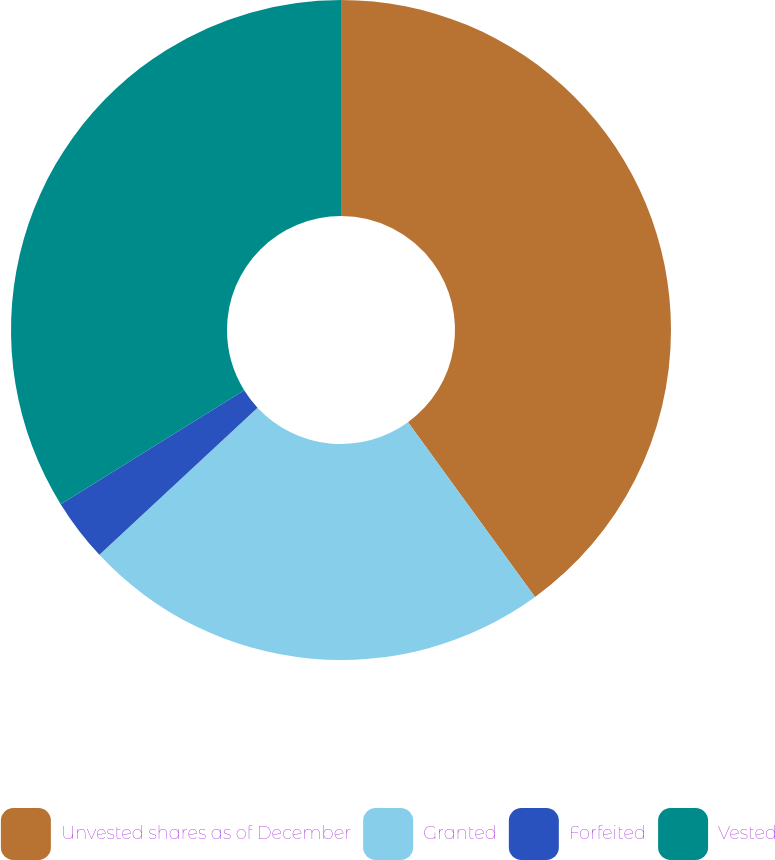Convert chart to OTSL. <chart><loc_0><loc_0><loc_500><loc_500><pie_chart><fcel>Unvested shares as of December<fcel>Granted<fcel>Forfeited<fcel>Vested<nl><fcel>40.0%<fcel>23.08%<fcel>3.08%<fcel>33.85%<nl></chart> 